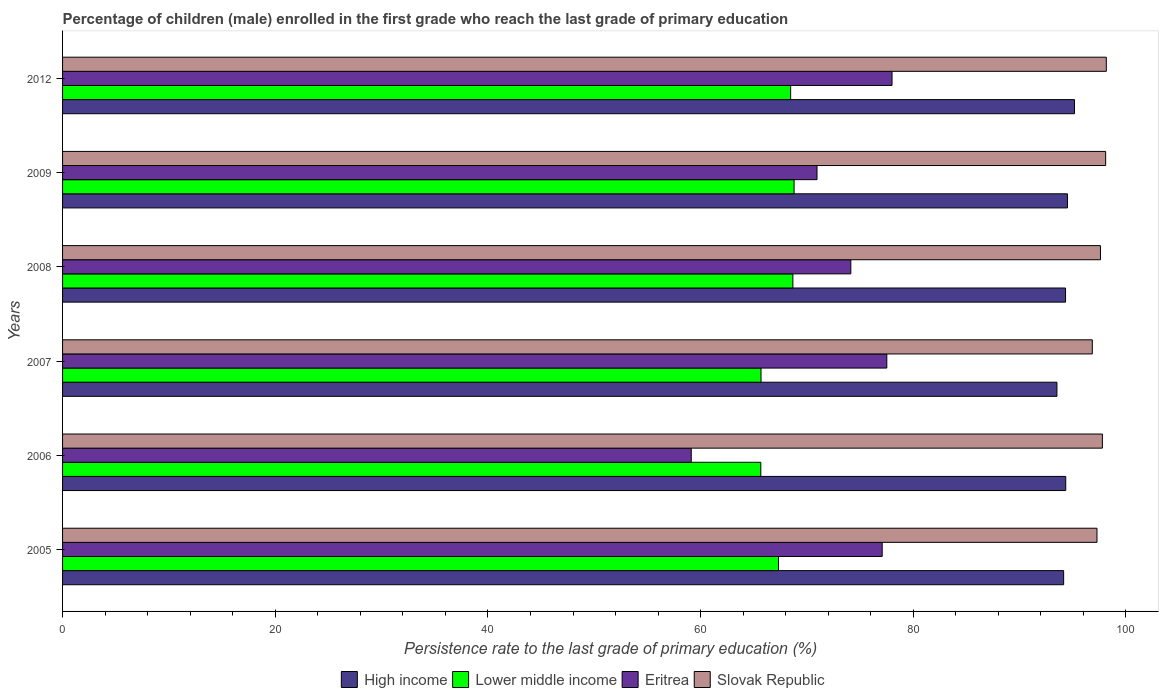How many different coloured bars are there?
Your answer should be compact. 4. Are the number of bars on each tick of the Y-axis equal?
Your answer should be very brief. Yes. How many bars are there on the 4th tick from the top?
Provide a succinct answer. 4. What is the label of the 4th group of bars from the top?
Offer a very short reply. 2007. What is the persistence rate of children in Lower middle income in 2005?
Provide a succinct answer. 67.33. Across all years, what is the maximum persistence rate of children in High income?
Make the answer very short. 95.16. Across all years, what is the minimum persistence rate of children in Slovak Republic?
Keep it short and to the point. 96.83. What is the total persistence rate of children in High income in the graph?
Your answer should be compact. 565.95. What is the difference between the persistence rate of children in High income in 2005 and that in 2012?
Keep it short and to the point. -1.02. What is the difference between the persistence rate of children in Eritrea in 2009 and the persistence rate of children in Lower middle income in 2008?
Ensure brevity in your answer.  2.27. What is the average persistence rate of children in Slovak Republic per year?
Provide a succinct answer. 97.62. In the year 2006, what is the difference between the persistence rate of children in Slovak Republic and persistence rate of children in Lower middle income?
Your answer should be compact. 32.12. In how many years, is the persistence rate of children in Eritrea greater than 36 %?
Make the answer very short. 6. What is the ratio of the persistence rate of children in High income in 2008 to that in 2009?
Give a very brief answer. 1. Is the persistence rate of children in Eritrea in 2005 less than that in 2006?
Offer a very short reply. No. Is the difference between the persistence rate of children in Slovak Republic in 2006 and 2009 greater than the difference between the persistence rate of children in Lower middle income in 2006 and 2009?
Your answer should be compact. Yes. What is the difference between the highest and the second highest persistence rate of children in Slovak Republic?
Ensure brevity in your answer.  0.06. What is the difference between the highest and the lowest persistence rate of children in Lower middle income?
Your answer should be compact. 3.13. Is the sum of the persistence rate of children in Eritrea in 2005 and 2009 greater than the maximum persistence rate of children in High income across all years?
Your response must be concise. Yes. What does the 2nd bar from the top in 2009 represents?
Keep it short and to the point. Eritrea. Is it the case that in every year, the sum of the persistence rate of children in High income and persistence rate of children in Lower middle income is greater than the persistence rate of children in Slovak Republic?
Offer a terse response. Yes. How many bars are there?
Offer a very short reply. 24. Are all the bars in the graph horizontal?
Give a very brief answer. Yes. How many years are there in the graph?
Your response must be concise. 6. What is the difference between two consecutive major ticks on the X-axis?
Give a very brief answer. 20. Does the graph contain any zero values?
Your answer should be compact. No. Does the graph contain grids?
Make the answer very short. No. What is the title of the graph?
Keep it short and to the point. Percentage of children (male) enrolled in the first grade who reach the last grade of primary education. What is the label or title of the X-axis?
Provide a succinct answer. Persistence rate to the last grade of primary education (%). What is the Persistence rate to the last grade of primary education (%) of High income in 2005?
Provide a succinct answer. 94.14. What is the Persistence rate to the last grade of primary education (%) of Lower middle income in 2005?
Offer a terse response. 67.33. What is the Persistence rate to the last grade of primary education (%) in Eritrea in 2005?
Offer a terse response. 77.08. What is the Persistence rate to the last grade of primary education (%) in Slovak Republic in 2005?
Your response must be concise. 97.27. What is the Persistence rate to the last grade of primary education (%) in High income in 2006?
Your answer should be very brief. 94.34. What is the Persistence rate to the last grade of primary education (%) in Lower middle income in 2006?
Your answer should be very brief. 65.66. What is the Persistence rate to the last grade of primary education (%) of Eritrea in 2006?
Give a very brief answer. 59.12. What is the Persistence rate to the last grade of primary education (%) of Slovak Republic in 2006?
Keep it short and to the point. 97.78. What is the Persistence rate to the last grade of primary education (%) in High income in 2007?
Provide a succinct answer. 93.51. What is the Persistence rate to the last grade of primary education (%) in Lower middle income in 2007?
Provide a short and direct response. 65.68. What is the Persistence rate to the last grade of primary education (%) in Eritrea in 2007?
Offer a very short reply. 77.51. What is the Persistence rate to the last grade of primary education (%) of Slovak Republic in 2007?
Provide a short and direct response. 96.83. What is the Persistence rate to the last grade of primary education (%) of High income in 2008?
Provide a short and direct response. 94.32. What is the Persistence rate to the last grade of primary education (%) of Lower middle income in 2008?
Your response must be concise. 68.68. What is the Persistence rate to the last grade of primary education (%) in Eritrea in 2008?
Your response must be concise. 74.13. What is the Persistence rate to the last grade of primary education (%) in Slovak Republic in 2008?
Offer a terse response. 97.6. What is the Persistence rate to the last grade of primary education (%) in High income in 2009?
Make the answer very short. 94.5. What is the Persistence rate to the last grade of primary education (%) in Lower middle income in 2009?
Your answer should be compact. 68.79. What is the Persistence rate to the last grade of primary education (%) of Eritrea in 2009?
Offer a very short reply. 70.95. What is the Persistence rate to the last grade of primary education (%) in Slovak Republic in 2009?
Your answer should be compact. 98.09. What is the Persistence rate to the last grade of primary education (%) in High income in 2012?
Your answer should be very brief. 95.16. What is the Persistence rate to the last grade of primary education (%) of Lower middle income in 2012?
Your response must be concise. 68.47. What is the Persistence rate to the last grade of primary education (%) in Eritrea in 2012?
Your response must be concise. 78. What is the Persistence rate to the last grade of primary education (%) in Slovak Republic in 2012?
Offer a very short reply. 98.15. Across all years, what is the maximum Persistence rate to the last grade of primary education (%) of High income?
Provide a short and direct response. 95.16. Across all years, what is the maximum Persistence rate to the last grade of primary education (%) in Lower middle income?
Provide a succinct answer. 68.79. Across all years, what is the maximum Persistence rate to the last grade of primary education (%) of Eritrea?
Your answer should be compact. 78. Across all years, what is the maximum Persistence rate to the last grade of primary education (%) in Slovak Republic?
Offer a terse response. 98.15. Across all years, what is the minimum Persistence rate to the last grade of primary education (%) in High income?
Provide a succinct answer. 93.51. Across all years, what is the minimum Persistence rate to the last grade of primary education (%) in Lower middle income?
Ensure brevity in your answer.  65.66. Across all years, what is the minimum Persistence rate to the last grade of primary education (%) of Eritrea?
Ensure brevity in your answer.  59.12. Across all years, what is the minimum Persistence rate to the last grade of primary education (%) in Slovak Republic?
Your answer should be very brief. 96.83. What is the total Persistence rate to the last grade of primary education (%) in High income in the graph?
Ensure brevity in your answer.  565.95. What is the total Persistence rate to the last grade of primary education (%) of Lower middle income in the graph?
Provide a succinct answer. 404.6. What is the total Persistence rate to the last grade of primary education (%) in Eritrea in the graph?
Your response must be concise. 436.78. What is the total Persistence rate to the last grade of primary education (%) of Slovak Republic in the graph?
Provide a short and direct response. 585.73. What is the difference between the Persistence rate to the last grade of primary education (%) in High income in 2005 and that in 2006?
Offer a terse response. -0.2. What is the difference between the Persistence rate to the last grade of primary education (%) in Lower middle income in 2005 and that in 2006?
Give a very brief answer. 1.67. What is the difference between the Persistence rate to the last grade of primary education (%) of Eritrea in 2005 and that in 2006?
Make the answer very short. 17.96. What is the difference between the Persistence rate to the last grade of primary education (%) in Slovak Republic in 2005 and that in 2006?
Keep it short and to the point. -0.51. What is the difference between the Persistence rate to the last grade of primary education (%) in High income in 2005 and that in 2007?
Give a very brief answer. 0.63. What is the difference between the Persistence rate to the last grade of primary education (%) in Lower middle income in 2005 and that in 2007?
Your response must be concise. 1.65. What is the difference between the Persistence rate to the last grade of primary education (%) in Eritrea in 2005 and that in 2007?
Ensure brevity in your answer.  -0.43. What is the difference between the Persistence rate to the last grade of primary education (%) in Slovak Republic in 2005 and that in 2007?
Your response must be concise. 0.44. What is the difference between the Persistence rate to the last grade of primary education (%) of High income in 2005 and that in 2008?
Give a very brief answer. -0.18. What is the difference between the Persistence rate to the last grade of primary education (%) in Lower middle income in 2005 and that in 2008?
Your response must be concise. -1.35. What is the difference between the Persistence rate to the last grade of primary education (%) in Eritrea in 2005 and that in 2008?
Offer a terse response. 2.95. What is the difference between the Persistence rate to the last grade of primary education (%) of Slovak Republic in 2005 and that in 2008?
Your answer should be compact. -0.33. What is the difference between the Persistence rate to the last grade of primary education (%) of High income in 2005 and that in 2009?
Ensure brevity in your answer.  -0.36. What is the difference between the Persistence rate to the last grade of primary education (%) of Lower middle income in 2005 and that in 2009?
Offer a very short reply. -1.46. What is the difference between the Persistence rate to the last grade of primary education (%) of Eritrea in 2005 and that in 2009?
Your response must be concise. 6.13. What is the difference between the Persistence rate to the last grade of primary education (%) in Slovak Republic in 2005 and that in 2009?
Ensure brevity in your answer.  -0.82. What is the difference between the Persistence rate to the last grade of primary education (%) of High income in 2005 and that in 2012?
Offer a very short reply. -1.02. What is the difference between the Persistence rate to the last grade of primary education (%) of Lower middle income in 2005 and that in 2012?
Make the answer very short. -1.14. What is the difference between the Persistence rate to the last grade of primary education (%) in Eritrea in 2005 and that in 2012?
Your answer should be compact. -0.93. What is the difference between the Persistence rate to the last grade of primary education (%) in Slovak Republic in 2005 and that in 2012?
Make the answer very short. -0.88. What is the difference between the Persistence rate to the last grade of primary education (%) of High income in 2006 and that in 2007?
Your answer should be very brief. 0.83. What is the difference between the Persistence rate to the last grade of primary education (%) of Lower middle income in 2006 and that in 2007?
Provide a short and direct response. -0.02. What is the difference between the Persistence rate to the last grade of primary education (%) of Eritrea in 2006 and that in 2007?
Your answer should be very brief. -18.39. What is the difference between the Persistence rate to the last grade of primary education (%) of Slovak Republic in 2006 and that in 2007?
Give a very brief answer. 0.95. What is the difference between the Persistence rate to the last grade of primary education (%) in High income in 2006 and that in 2008?
Offer a terse response. 0.02. What is the difference between the Persistence rate to the last grade of primary education (%) of Lower middle income in 2006 and that in 2008?
Offer a very short reply. -3.01. What is the difference between the Persistence rate to the last grade of primary education (%) in Eritrea in 2006 and that in 2008?
Provide a succinct answer. -15.01. What is the difference between the Persistence rate to the last grade of primary education (%) in Slovak Republic in 2006 and that in 2008?
Ensure brevity in your answer.  0.18. What is the difference between the Persistence rate to the last grade of primary education (%) of High income in 2006 and that in 2009?
Your answer should be compact. -0.16. What is the difference between the Persistence rate to the last grade of primary education (%) of Lower middle income in 2006 and that in 2009?
Ensure brevity in your answer.  -3.13. What is the difference between the Persistence rate to the last grade of primary education (%) of Eritrea in 2006 and that in 2009?
Ensure brevity in your answer.  -11.83. What is the difference between the Persistence rate to the last grade of primary education (%) in Slovak Republic in 2006 and that in 2009?
Make the answer very short. -0.31. What is the difference between the Persistence rate to the last grade of primary education (%) in High income in 2006 and that in 2012?
Your answer should be compact. -0.82. What is the difference between the Persistence rate to the last grade of primary education (%) of Lower middle income in 2006 and that in 2012?
Offer a very short reply. -2.8. What is the difference between the Persistence rate to the last grade of primary education (%) of Eritrea in 2006 and that in 2012?
Ensure brevity in your answer.  -18.88. What is the difference between the Persistence rate to the last grade of primary education (%) of Slovak Republic in 2006 and that in 2012?
Provide a short and direct response. -0.37. What is the difference between the Persistence rate to the last grade of primary education (%) in High income in 2007 and that in 2008?
Offer a terse response. -0.81. What is the difference between the Persistence rate to the last grade of primary education (%) in Lower middle income in 2007 and that in 2008?
Keep it short and to the point. -2.99. What is the difference between the Persistence rate to the last grade of primary education (%) in Eritrea in 2007 and that in 2008?
Provide a short and direct response. 3.38. What is the difference between the Persistence rate to the last grade of primary education (%) in Slovak Republic in 2007 and that in 2008?
Keep it short and to the point. -0.77. What is the difference between the Persistence rate to the last grade of primary education (%) in High income in 2007 and that in 2009?
Offer a terse response. -0.99. What is the difference between the Persistence rate to the last grade of primary education (%) of Lower middle income in 2007 and that in 2009?
Ensure brevity in your answer.  -3.11. What is the difference between the Persistence rate to the last grade of primary education (%) in Eritrea in 2007 and that in 2009?
Provide a succinct answer. 6.56. What is the difference between the Persistence rate to the last grade of primary education (%) in Slovak Republic in 2007 and that in 2009?
Ensure brevity in your answer.  -1.26. What is the difference between the Persistence rate to the last grade of primary education (%) in High income in 2007 and that in 2012?
Ensure brevity in your answer.  -1.65. What is the difference between the Persistence rate to the last grade of primary education (%) in Lower middle income in 2007 and that in 2012?
Ensure brevity in your answer.  -2.78. What is the difference between the Persistence rate to the last grade of primary education (%) in Eritrea in 2007 and that in 2012?
Make the answer very short. -0.49. What is the difference between the Persistence rate to the last grade of primary education (%) of Slovak Republic in 2007 and that in 2012?
Provide a short and direct response. -1.32. What is the difference between the Persistence rate to the last grade of primary education (%) of High income in 2008 and that in 2009?
Your response must be concise. -0.18. What is the difference between the Persistence rate to the last grade of primary education (%) in Lower middle income in 2008 and that in 2009?
Keep it short and to the point. -0.11. What is the difference between the Persistence rate to the last grade of primary education (%) of Eritrea in 2008 and that in 2009?
Provide a short and direct response. 3.18. What is the difference between the Persistence rate to the last grade of primary education (%) in Slovak Republic in 2008 and that in 2009?
Offer a terse response. -0.49. What is the difference between the Persistence rate to the last grade of primary education (%) of High income in 2008 and that in 2012?
Your response must be concise. -0.84. What is the difference between the Persistence rate to the last grade of primary education (%) in Lower middle income in 2008 and that in 2012?
Your answer should be compact. 0.21. What is the difference between the Persistence rate to the last grade of primary education (%) in Eritrea in 2008 and that in 2012?
Give a very brief answer. -3.87. What is the difference between the Persistence rate to the last grade of primary education (%) of Slovak Republic in 2008 and that in 2012?
Offer a very short reply. -0.55. What is the difference between the Persistence rate to the last grade of primary education (%) of High income in 2009 and that in 2012?
Provide a succinct answer. -0.66. What is the difference between the Persistence rate to the last grade of primary education (%) in Lower middle income in 2009 and that in 2012?
Provide a short and direct response. 0.32. What is the difference between the Persistence rate to the last grade of primary education (%) of Eritrea in 2009 and that in 2012?
Provide a short and direct response. -7.06. What is the difference between the Persistence rate to the last grade of primary education (%) of Slovak Republic in 2009 and that in 2012?
Keep it short and to the point. -0.06. What is the difference between the Persistence rate to the last grade of primary education (%) of High income in 2005 and the Persistence rate to the last grade of primary education (%) of Lower middle income in 2006?
Make the answer very short. 28.48. What is the difference between the Persistence rate to the last grade of primary education (%) in High income in 2005 and the Persistence rate to the last grade of primary education (%) in Eritrea in 2006?
Provide a short and direct response. 35.02. What is the difference between the Persistence rate to the last grade of primary education (%) in High income in 2005 and the Persistence rate to the last grade of primary education (%) in Slovak Republic in 2006?
Your answer should be compact. -3.64. What is the difference between the Persistence rate to the last grade of primary education (%) of Lower middle income in 2005 and the Persistence rate to the last grade of primary education (%) of Eritrea in 2006?
Your response must be concise. 8.21. What is the difference between the Persistence rate to the last grade of primary education (%) in Lower middle income in 2005 and the Persistence rate to the last grade of primary education (%) in Slovak Republic in 2006?
Make the answer very short. -30.45. What is the difference between the Persistence rate to the last grade of primary education (%) in Eritrea in 2005 and the Persistence rate to the last grade of primary education (%) in Slovak Republic in 2006?
Your response must be concise. -20.71. What is the difference between the Persistence rate to the last grade of primary education (%) of High income in 2005 and the Persistence rate to the last grade of primary education (%) of Lower middle income in 2007?
Offer a terse response. 28.46. What is the difference between the Persistence rate to the last grade of primary education (%) of High income in 2005 and the Persistence rate to the last grade of primary education (%) of Eritrea in 2007?
Make the answer very short. 16.63. What is the difference between the Persistence rate to the last grade of primary education (%) of High income in 2005 and the Persistence rate to the last grade of primary education (%) of Slovak Republic in 2007?
Offer a terse response. -2.69. What is the difference between the Persistence rate to the last grade of primary education (%) of Lower middle income in 2005 and the Persistence rate to the last grade of primary education (%) of Eritrea in 2007?
Ensure brevity in your answer.  -10.18. What is the difference between the Persistence rate to the last grade of primary education (%) of Lower middle income in 2005 and the Persistence rate to the last grade of primary education (%) of Slovak Republic in 2007?
Provide a succinct answer. -29.51. What is the difference between the Persistence rate to the last grade of primary education (%) of Eritrea in 2005 and the Persistence rate to the last grade of primary education (%) of Slovak Republic in 2007?
Your response must be concise. -19.76. What is the difference between the Persistence rate to the last grade of primary education (%) in High income in 2005 and the Persistence rate to the last grade of primary education (%) in Lower middle income in 2008?
Provide a succinct answer. 25.46. What is the difference between the Persistence rate to the last grade of primary education (%) of High income in 2005 and the Persistence rate to the last grade of primary education (%) of Eritrea in 2008?
Keep it short and to the point. 20.01. What is the difference between the Persistence rate to the last grade of primary education (%) of High income in 2005 and the Persistence rate to the last grade of primary education (%) of Slovak Republic in 2008?
Ensure brevity in your answer.  -3.46. What is the difference between the Persistence rate to the last grade of primary education (%) of Lower middle income in 2005 and the Persistence rate to the last grade of primary education (%) of Eritrea in 2008?
Provide a short and direct response. -6.8. What is the difference between the Persistence rate to the last grade of primary education (%) of Lower middle income in 2005 and the Persistence rate to the last grade of primary education (%) of Slovak Republic in 2008?
Provide a succinct answer. -30.27. What is the difference between the Persistence rate to the last grade of primary education (%) in Eritrea in 2005 and the Persistence rate to the last grade of primary education (%) in Slovak Republic in 2008?
Offer a very short reply. -20.53. What is the difference between the Persistence rate to the last grade of primary education (%) of High income in 2005 and the Persistence rate to the last grade of primary education (%) of Lower middle income in 2009?
Offer a very short reply. 25.35. What is the difference between the Persistence rate to the last grade of primary education (%) in High income in 2005 and the Persistence rate to the last grade of primary education (%) in Eritrea in 2009?
Offer a very short reply. 23.19. What is the difference between the Persistence rate to the last grade of primary education (%) of High income in 2005 and the Persistence rate to the last grade of primary education (%) of Slovak Republic in 2009?
Give a very brief answer. -3.95. What is the difference between the Persistence rate to the last grade of primary education (%) of Lower middle income in 2005 and the Persistence rate to the last grade of primary education (%) of Eritrea in 2009?
Ensure brevity in your answer.  -3.62. What is the difference between the Persistence rate to the last grade of primary education (%) of Lower middle income in 2005 and the Persistence rate to the last grade of primary education (%) of Slovak Republic in 2009?
Provide a succinct answer. -30.76. What is the difference between the Persistence rate to the last grade of primary education (%) in Eritrea in 2005 and the Persistence rate to the last grade of primary education (%) in Slovak Republic in 2009?
Your answer should be very brief. -21.01. What is the difference between the Persistence rate to the last grade of primary education (%) in High income in 2005 and the Persistence rate to the last grade of primary education (%) in Lower middle income in 2012?
Keep it short and to the point. 25.67. What is the difference between the Persistence rate to the last grade of primary education (%) of High income in 2005 and the Persistence rate to the last grade of primary education (%) of Eritrea in 2012?
Provide a short and direct response. 16.14. What is the difference between the Persistence rate to the last grade of primary education (%) in High income in 2005 and the Persistence rate to the last grade of primary education (%) in Slovak Republic in 2012?
Give a very brief answer. -4.01. What is the difference between the Persistence rate to the last grade of primary education (%) of Lower middle income in 2005 and the Persistence rate to the last grade of primary education (%) of Eritrea in 2012?
Keep it short and to the point. -10.67. What is the difference between the Persistence rate to the last grade of primary education (%) in Lower middle income in 2005 and the Persistence rate to the last grade of primary education (%) in Slovak Republic in 2012?
Your response must be concise. -30.82. What is the difference between the Persistence rate to the last grade of primary education (%) of Eritrea in 2005 and the Persistence rate to the last grade of primary education (%) of Slovak Republic in 2012?
Make the answer very short. -21.07. What is the difference between the Persistence rate to the last grade of primary education (%) in High income in 2006 and the Persistence rate to the last grade of primary education (%) in Lower middle income in 2007?
Your answer should be very brief. 28.65. What is the difference between the Persistence rate to the last grade of primary education (%) of High income in 2006 and the Persistence rate to the last grade of primary education (%) of Eritrea in 2007?
Provide a succinct answer. 16.83. What is the difference between the Persistence rate to the last grade of primary education (%) in High income in 2006 and the Persistence rate to the last grade of primary education (%) in Slovak Republic in 2007?
Offer a very short reply. -2.5. What is the difference between the Persistence rate to the last grade of primary education (%) of Lower middle income in 2006 and the Persistence rate to the last grade of primary education (%) of Eritrea in 2007?
Give a very brief answer. -11.85. What is the difference between the Persistence rate to the last grade of primary education (%) of Lower middle income in 2006 and the Persistence rate to the last grade of primary education (%) of Slovak Republic in 2007?
Give a very brief answer. -31.17. What is the difference between the Persistence rate to the last grade of primary education (%) of Eritrea in 2006 and the Persistence rate to the last grade of primary education (%) of Slovak Republic in 2007?
Offer a very short reply. -37.71. What is the difference between the Persistence rate to the last grade of primary education (%) in High income in 2006 and the Persistence rate to the last grade of primary education (%) in Lower middle income in 2008?
Your response must be concise. 25.66. What is the difference between the Persistence rate to the last grade of primary education (%) in High income in 2006 and the Persistence rate to the last grade of primary education (%) in Eritrea in 2008?
Provide a succinct answer. 20.21. What is the difference between the Persistence rate to the last grade of primary education (%) in High income in 2006 and the Persistence rate to the last grade of primary education (%) in Slovak Republic in 2008?
Offer a very short reply. -3.27. What is the difference between the Persistence rate to the last grade of primary education (%) in Lower middle income in 2006 and the Persistence rate to the last grade of primary education (%) in Eritrea in 2008?
Provide a short and direct response. -8.46. What is the difference between the Persistence rate to the last grade of primary education (%) in Lower middle income in 2006 and the Persistence rate to the last grade of primary education (%) in Slovak Republic in 2008?
Your answer should be compact. -31.94. What is the difference between the Persistence rate to the last grade of primary education (%) in Eritrea in 2006 and the Persistence rate to the last grade of primary education (%) in Slovak Republic in 2008?
Keep it short and to the point. -38.48. What is the difference between the Persistence rate to the last grade of primary education (%) of High income in 2006 and the Persistence rate to the last grade of primary education (%) of Lower middle income in 2009?
Your answer should be very brief. 25.55. What is the difference between the Persistence rate to the last grade of primary education (%) of High income in 2006 and the Persistence rate to the last grade of primary education (%) of Eritrea in 2009?
Ensure brevity in your answer.  23.39. What is the difference between the Persistence rate to the last grade of primary education (%) in High income in 2006 and the Persistence rate to the last grade of primary education (%) in Slovak Republic in 2009?
Your response must be concise. -3.75. What is the difference between the Persistence rate to the last grade of primary education (%) in Lower middle income in 2006 and the Persistence rate to the last grade of primary education (%) in Eritrea in 2009?
Keep it short and to the point. -5.28. What is the difference between the Persistence rate to the last grade of primary education (%) of Lower middle income in 2006 and the Persistence rate to the last grade of primary education (%) of Slovak Republic in 2009?
Ensure brevity in your answer.  -32.43. What is the difference between the Persistence rate to the last grade of primary education (%) of Eritrea in 2006 and the Persistence rate to the last grade of primary education (%) of Slovak Republic in 2009?
Provide a short and direct response. -38.97. What is the difference between the Persistence rate to the last grade of primary education (%) in High income in 2006 and the Persistence rate to the last grade of primary education (%) in Lower middle income in 2012?
Offer a very short reply. 25.87. What is the difference between the Persistence rate to the last grade of primary education (%) of High income in 2006 and the Persistence rate to the last grade of primary education (%) of Eritrea in 2012?
Keep it short and to the point. 16.33. What is the difference between the Persistence rate to the last grade of primary education (%) in High income in 2006 and the Persistence rate to the last grade of primary education (%) in Slovak Republic in 2012?
Make the answer very short. -3.82. What is the difference between the Persistence rate to the last grade of primary education (%) in Lower middle income in 2006 and the Persistence rate to the last grade of primary education (%) in Eritrea in 2012?
Your answer should be compact. -12.34. What is the difference between the Persistence rate to the last grade of primary education (%) of Lower middle income in 2006 and the Persistence rate to the last grade of primary education (%) of Slovak Republic in 2012?
Make the answer very short. -32.49. What is the difference between the Persistence rate to the last grade of primary education (%) in Eritrea in 2006 and the Persistence rate to the last grade of primary education (%) in Slovak Republic in 2012?
Offer a terse response. -39.03. What is the difference between the Persistence rate to the last grade of primary education (%) of High income in 2007 and the Persistence rate to the last grade of primary education (%) of Lower middle income in 2008?
Ensure brevity in your answer.  24.83. What is the difference between the Persistence rate to the last grade of primary education (%) of High income in 2007 and the Persistence rate to the last grade of primary education (%) of Eritrea in 2008?
Your response must be concise. 19.38. What is the difference between the Persistence rate to the last grade of primary education (%) in High income in 2007 and the Persistence rate to the last grade of primary education (%) in Slovak Republic in 2008?
Give a very brief answer. -4.09. What is the difference between the Persistence rate to the last grade of primary education (%) of Lower middle income in 2007 and the Persistence rate to the last grade of primary education (%) of Eritrea in 2008?
Provide a short and direct response. -8.44. What is the difference between the Persistence rate to the last grade of primary education (%) of Lower middle income in 2007 and the Persistence rate to the last grade of primary education (%) of Slovak Republic in 2008?
Offer a very short reply. -31.92. What is the difference between the Persistence rate to the last grade of primary education (%) of Eritrea in 2007 and the Persistence rate to the last grade of primary education (%) of Slovak Republic in 2008?
Your answer should be very brief. -20.09. What is the difference between the Persistence rate to the last grade of primary education (%) of High income in 2007 and the Persistence rate to the last grade of primary education (%) of Lower middle income in 2009?
Provide a succinct answer. 24.72. What is the difference between the Persistence rate to the last grade of primary education (%) in High income in 2007 and the Persistence rate to the last grade of primary education (%) in Eritrea in 2009?
Make the answer very short. 22.56. What is the difference between the Persistence rate to the last grade of primary education (%) of High income in 2007 and the Persistence rate to the last grade of primary education (%) of Slovak Republic in 2009?
Give a very brief answer. -4.58. What is the difference between the Persistence rate to the last grade of primary education (%) in Lower middle income in 2007 and the Persistence rate to the last grade of primary education (%) in Eritrea in 2009?
Your answer should be compact. -5.26. What is the difference between the Persistence rate to the last grade of primary education (%) in Lower middle income in 2007 and the Persistence rate to the last grade of primary education (%) in Slovak Republic in 2009?
Your answer should be very brief. -32.41. What is the difference between the Persistence rate to the last grade of primary education (%) of Eritrea in 2007 and the Persistence rate to the last grade of primary education (%) of Slovak Republic in 2009?
Your response must be concise. -20.58. What is the difference between the Persistence rate to the last grade of primary education (%) in High income in 2007 and the Persistence rate to the last grade of primary education (%) in Lower middle income in 2012?
Offer a terse response. 25.04. What is the difference between the Persistence rate to the last grade of primary education (%) in High income in 2007 and the Persistence rate to the last grade of primary education (%) in Eritrea in 2012?
Give a very brief answer. 15.51. What is the difference between the Persistence rate to the last grade of primary education (%) of High income in 2007 and the Persistence rate to the last grade of primary education (%) of Slovak Republic in 2012?
Provide a succinct answer. -4.64. What is the difference between the Persistence rate to the last grade of primary education (%) in Lower middle income in 2007 and the Persistence rate to the last grade of primary education (%) in Eritrea in 2012?
Ensure brevity in your answer.  -12.32. What is the difference between the Persistence rate to the last grade of primary education (%) in Lower middle income in 2007 and the Persistence rate to the last grade of primary education (%) in Slovak Republic in 2012?
Offer a terse response. -32.47. What is the difference between the Persistence rate to the last grade of primary education (%) in Eritrea in 2007 and the Persistence rate to the last grade of primary education (%) in Slovak Republic in 2012?
Your response must be concise. -20.64. What is the difference between the Persistence rate to the last grade of primary education (%) in High income in 2008 and the Persistence rate to the last grade of primary education (%) in Lower middle income in 2009?
Offer a very short reply. 25.53. What is the difference between the Persistence rate to the last grade of primary education (%) of High income in 2008 and the Persistence rate to the last grade of primary education (%) of Eritrea in 2009?
Give a very brief answer. 23.37. What is the difference between the Persistence rate to the last grade of primary education (%) of High income in 2008 and the Persistence rate to the last grade of primary education (%) of Slovak Republic in 2009?
Your answer should be very brief. -3.77. What is the difference between the Persistence rate to the last grade of primary education (%) in Lower middle income in 2008 and the Persistence rate to the last grade of primary education (%) in Eritrea in 2009?
Your answer should be compact. -2.27. What is the difference between the Persistence rate to the last grade of primary education (%) of Lower middle income in 2008 and the Persistence rate to the last grade of primary education (%) of Slovak Republic in 2009?
Your answer should be compact. -29.41. What is the difference between the Persistence rate to the last grade of primary education (%) in Eritrea in 2008 and the Persistence rate to the last grade of primary education (%) in Slovak Republic in 2009?
Offer a terse response. -23.96. What is the difference between the Persistence rate to the last grade of primary education (%) in High income in 2008 and the Persistence rate to the last grade of primary education (%) in Lower middle income in 2012?
Give a very brief answer. 25.85. What is the difference between the Persistence rate to the last grade of primary education (%) of High income in 2008 and the Persistence rate to the last grade of primary education (%) of Eritrea in 2012?
Provide a succinct answer. 16.32. What is the difference between the Persistence rate to the last grade of primary education (%) of High income in 2008 and the Persistence rate to the last grade of primary education (%) of Slovak Republic in 2012?
Offer a very short reply. -3.83. What is the difference between the Persistence rate to the last grade of primary education (%) in Lower middle income in 2008 and the Persistence rate to the last grade of primary education (%) in Eritrea in 2012?
Keep it short and to the point. -9.32. What is the difference between the Persistence rate to the last grade of primary education (%) in Lower middle income in 2008 and the Persistence rate to the last grade of primary education (%) in Slovak Republic in 2012?
Your answer should be compact. -29.47. What is the difference between the Persistence rate to the last grade of primary education (%) of Eritrea in 2008 and the Persistence rate to the last grade of primary education (%) of Slovak Republic in 2012?
Offer a very short reply. -24.02. What is the difference between the Persistence rate to the last grade of primary education (%) in High income in 2009 and the Persistence rate to the last grade of primary education (%) in Lower middle income in 2012?
Provide a short and direct response. 26.03. What is the difference between the Persistence rate to the last grade of primary education (%) in High income in 2009 and the Persistence rate to the last grade of primary education (%) in Eritrea in 2012?
Give a very brief answer. 16.5. What is the difference between the Persistence rate to the last grade of primary education (%) in High income in 2009 and the Persistence rate to the last grade of primary education (%) in Slovak Republic in 2012?
Keep it short and to the point. -3.65. What is the difference between the Persistence rate to the last grade of primary education (%) in Lower middle income in 2009 and the Persistence rate to the last grade of primary education (%) in Eritrea in 2012?
Your answer should be very brief. -9.21. What is the difference between the Persistence rate to the last grade of primary education (%) in Lower middle income in 2009 and the Persistence rate to the last grade of primary education (%) in Slovak Republic in 2012?
Your answer should be compact. -29.36. What is the difference between the Persistence rate to the last grade of primary education (%) in Eritrea in 2009 and the Persistence rate to the last grade of primary education (%) in Slovak Republic in 2012?
Your response must be concise. -27.2. What is the average Persistence rate to the last grade of primary education (%) of High income per year?
Ensure brevity in your answer.  94.33. What is the average Persistence rate to the last grade of primary education (%) of Lower middle income per year?
Provide a short and direct response. 67.43. What is the average Persistence rate to the last grade of primary education (%) of Eritrea per year?
Make the answer very short. 72.8. What is the average Persistence rate to the last grade of primary education (%) in Slovak Republic per year?
Provide a succinct answer. 97.62. In the year 2005, what is the difference between the Persistence rate to the last grade of primary education (%) of High income and Persistence rate to the last grade of primary education (%) of Lower middle income?
Your answer should be compact. 26.81. In the year 2005, what is the difference between the Persistence rate to the last grade of primary education (%) in High income and Persistence rate to the last grade of primary education (%) in Eritrea?
Your answer should be very brief. 17.06. In the year 2005, what is the difference between the Persistence rate to the last grade of primary education (%) of High income and Persistence rate to the last grade of primary education (%) of Slovak Republic?
Offer a terse response. -3.14. In the year 2005, what is the difference between the Persistence rate to the last grade of primary education (%) in Lower middle income and Persistence rate to the last grade of primary education (%) in Eritrea?
Provide a short and direct response. -9.75. In the year 2005, what is the difference between the Persistence rate to the last grade of primary education (%) of Lower middle income and Persistence rate to the last grade of primary education (%) of Slovak Republic?
Your answer should be very brief. -29.95. In the year 2005, what is the difference between the Persistence rate to the last grade of primary education (%) of Eritrea and Persistence rate to the last grade of primary education (%) of Slovak Republic?
Your answer should be compact. -20.2. In the year 2006, what is the difference between the Persistence rate to the last grade of primary education (%) of High income and Persistence rate to the last grade of primary education (%) of Lower middle income?
Provide a succinct answer. 28.67. In the year 2006, what is the difference between the Persistence rate to the last grade of primary education (%) in High income and Persistence rate to the last grade of primary education (%) in Eritrea?
Make the answer very short. 35.22. In the year 2006, what is the difference between the Persistence rate to the last grade of primary education (%) of High income and Persistence rate to the last grade of primary education (%) of Slovak Republic?
Your answer should be very brief. -3.45. In the year 2006, what is the difference between the Persistence rate to the last grade of primary education (%) of Lower middle income and Persistence rate to the last grade of primary education (%) of Eritrea?
Offer a very short reply. 6.54. In the year 2006, what is the difference between the Persistence rate to the last grade of primary education (%) in Lower middle income and Persistence rate to the last grade of primary education (%) in Slovak Republic?
Give a very brief answer. -32.12. In the year 2006, what is the difference between the Persistence rate to the last grade of primary education (%) in Eritrea and Persistence rate to the last grade of primary education (%) in Slovak Republic?
Give a very brief answer. -38.66. In the year 2007, what is the difference between the Persistence rate to the last grade of primary education (%) in High income and Persistence rate to the last grade of primary education (%) in Lower middle income?
Provide a short and direct response. 27.83. In the year 2007, what is the difference between the Persistence rate to the last grade of primary education (%) in High income and Persistence rate to the last grade of primary education (%) in Eritrea?
Your answer should be compact. 16. In the year 2007, what is the difference between the Persistence rate to the last grade of primary education (%) in High income and Persistence rate to the last grade of primary education (%) in Slovak Republic?
Offer a terse response. -3.33. In the year 2007, what is the difference between the Persistence rate to the last grade of primary education (%) in Lower middle income and Persistence rate to the last grade of primary education (%) in Eritrea?
Give a very brief answer. -11.83. In the year 2007, what is the difference between the Persistence rate to the last grade of primary education (%) of Lower middle income and Persistence rate to the last grade of primary education (%) of Slovak Republic?
Your answer should be very brief. -31.15. In the year 2007, what is the difference between the Persistence rate to the last grade of primary education (%) in Eritrea and Persistence rate to the last grade of primary education (%) in Slovak Republic?
Make the answer very short. -19.32. In the year 2008, what is the difference between the Persistence rate to the last grade of primary education (%) in High income and Persistence rate to the last grade of primary education (%) in Lower middle income?
Offer a very short reply. 25.64. In the year 2008, what is the difference between the Persistence rate to the last grade of primary education (%) of High income and Persistence rate to the last grade of primary education (%) of Eritrea?
Your answer should be very brief. 20.19. In the year 2008, what is the difference between the Persistence rate to the last grade of primary education (%) in High income and Persistence rate to the last grade of primary education (%) in Slovak Republic?
Ensure brevity in your answer.  -3.28. In the year 2008, what is the difference between the Persistence rate to the last grade of primary education (%) of Lower middle income and Persistence rate to the last grade of primary education (%) of Eritrea?
Give a very brief answer. -5.45. In the year 2008, what is the difference between the Persistence rate to the last grade of primary education (%) of Lower middle income and Persistence rate to the last grade of primary education (%) of Slovak Republic?
Offer a terse response. -28.92. In the year 2008, what is the difference between the Persistence rate to the last grade of primary education (%) of Eritrea and Persistence rate to the last grade of primary education (%) of Slovak Republic?
Your answer should be compact. -23.47. In the year 2009, what is the difference between the Persistence rate to the last grade of primary education (%) of High income and Persistence rate to the last grade of primary education (%) of Lower middle income?
Provide a succinct answer. 25.71. In the year 2009, what is the difference between the Persistence rate to the last grade of primary education (%) of High income and Persistence rate to the last grade of primary education (%) of Eritrea?
Provide a short and direct response. 23.55. In the year 2009, what is the difference between the Persistence rate to the last grade of primary education (%) of High income and Persistence rate to the last grade of primary education (%) of Slovak Republic?
Offer a terse response. -3.59. In the year 2009, what is the difference between the Persistence rate to the last grade of primary education (%) of Lower middle income and Persistence rate to the last grade of primary education (%) of Eritrea?
Give a very brief answer. -2.16. In the year 2009, what is the difference between the Persistence rate to the last grade of primary education (%) in Lower middle income and Persistence rate to the last grade of primary education (%) in Slovak Republic?
Your answer should be compact. -29.3. In the year 2009, what is the difference between the Persistence rate to the last grade of primary education (%) of Eritrea and Persistence rate to the last grade of primary education (%) of Slovak Republic?
Keep it short and to the point. -27.14. In the year 2012, what is the difference between the Persistence rate to the last grade of primary education (%) in High income and Persistence rate to the last grade of primary education (%) in Lower middle income?
Your answer should be very brief. 26.69. In the year 2012, what is the difference between the Persistence rate to the last grade of primary education (%) of High income and Persistence rate to the last grade of primary education (%) of Eritrea?
Keep it short and to the point. 17.16. In the year 2012, what is the difference between the Persistence rate to the last grade of primary education (%) of High income and Persistence rate to the last grade of primary education (%) of Slovak Republic?
Provide a short and direct response. -2.99. In the year 2012, what is the difference between the Persistence rate to the last grade of primary education (%) of Lower middle income and Persistence rate to the last grade of primary education (%) of Eritrea?
Ensure brevity in your answer.  -9.53. In the year 2012, what is the difference between the Persistence rate to the last grade of primary education (%) of Lower middle income and Persistence rate to the last grade of primary education (%) of Slovak Republic?
Your response must be concise. -29.68. In the year 2012, what is the difference between the Persistence rate to the last grade of primary education (%) of Eritrea and Persistence rate to the last grade of primary education (%) of Slovak Republic?
Make the answer very short. -20.15. What is the ratio of the Persistence rate to the last grade of primary education (%) in High income in 2005 to that in 2006?
Ensure brevity in your answer.  1. What is the ratio of the Persistence rate to the last grade of primary education (%) in Lower middle income in 2005 to that in 2006?
Provide a succinct answer. 1.03. What is the ratio of the Persistence rate to the last grade of primary education (%) of Eritrea in 2005 to that in 2006?
Keep it short and to the point. 1.3. What is the ratio of the Persistence rate to the last grade of primary education (%) of High income in 2005 to that in 2007?
Give a very brief answer. 1.01. What is the ratio of the Persistence rate to the last grade of primary education (%) of Lower middle income in 2005 to that in 2007?
Ensure brevity in your answer.  1.03. What is the ratio of the Persistence rate to the last grade of primary education (%) of High income in 2005 to that in 2008?
Offer a terse response. 1. What is the ratio of the Persistence rate to the last grade of primary education (%) in Lower middle income in 2005 to that in 2008?
Your answer should be very brief. 0.98. What is the ratio of the Persistence rate to the last grade of primary education (%) of Eritrea in 2005 to that in 2008?
Provide a short and direct response. 1.04. What is the ratio of the Persistence rate to the last grade of primary education (%) in Lower middle income in 2005 to that in 2009?
Make the answer very short. 0.98. What is the ratio of the Persistence rate to the last grade of primary education (%) in Eritrea in 2005 to that in 2009?
Make the answer very short. 1.09. What is the ratio of the Persistence rate to the last grade of primary education (%) in Slovak Republic in 2005 to that in 2009?
Provide a succinct answer. 0.99. What is the ratio of the Persistence rate to the last grade of primary education (%) of High income in 2005 to that in 2012?
Keep it short and to the point. 0.99. What is the ratio of the Persistence rate to the last grade of primary education (%) of Lower middle income in 2005 to that in 2012?
Offer a very short reply. 0.98. What is the ratio of the Persistence rate to the last grade of primary education (%) in Eritrea in 2005 to that in 2012?
Make the answer very short. 0.99. What is the ratio of the Persistence rate to the last grade of primary education (%) of High income in 2006 to that in 2007?
Provide a short and direct response. 1.01. What is the ratio of the Persistence rate to the last grade of primary education (%) in Eritrea in 2006 to that in 2007?
Ensure brevity in your answer.  0.76. What is the ratio of the Persistence rate to the last grade of primary education (%) in Slovak Republic in 2006 to that in 2007?
Offer a very short reply. 1.01. What is the ratio of the Persistence rate to the last grade of primary education (%) in Lower middle income in 2006 to that in 2008?
Ensure brevity in your answer.  0.96. What is the ratio of the Persistence rate to the last grade of primary education (%) in Eritrea in 2006 to that in 2008?
Your answer should be compact. 0.8. What is the ratio of the Persistence rate to the last grade of primary education (%) in Slovak Republic in 2006 to that in 2008?
Offer a very short reply. 1. What is the ratio of the Persistence rate to the last grade of primary education (%) of Lower middle income in 2006 to that in 2009?
Offer a terse response. 0.95. What is the ratio of the Persistence rate to the last grade of primary education (%) of Eritrea in 2006 to that in 2009?
Ensure brevity in your answer.  0.83. What is the ratio of the Persistence rate to the last grade of primary education (%) in Slovak Republic in 2006 to that in 2009?
Ensure brevity in your answer.  1. What is the ratio of the Persistence rate to the last grade of primary education (%) of High income in 2006 to that in 2012?
Ensure brevity in your answer.  0.99. What is the ratio of the Persistence rate to the last grade of primary education (%) in Lower middle income in 2006 to that in 2012?
Your response must be concise. 0.96. What is the ratio of the Persistence rate to the last grade of primary education (%) in Eritrea in 2006 to that in 2012?
Your response must be concise. 0.76. What is the ratio of the Persistence rate to the last grade of primary education (%) in Slovak Republic in 2006 to that in 2012?
Offer a terse response. 1. What is the ratio of the Persistence rate to the last grade of primary education (%) in High income in 2007 to that in 2008?
Offer a very short reply. 0.99. What is the ratio of the Persistence rate to the last grade of primary education (%) of Lower middle income in 2007 to that in 2008?
Offer a very short reply. 0.96. What is the ratio of the Persistence rate to the last grade of primary education (%) in Eritrea in 2007 to that in 2008?
Ensure brevity in your answer.  1.05. What is the ratio of the Persistence rate to the last grade of primary education (%) of Slovak Republic in 2007 to that in 2008?
Offer a terse response. 0.99. What is the ratio of the Persistence rate to the last grade of primary education (%) in High income in 2007 to that in 2009?
Give a very brief answer. 0.99. What is the ratio of the Persistence rate to the last grade of primary education (%) of Lower middle income in 2007 to that in 2009?
Your answer should be compact. 0.95. What is the ratio of the Persistence rate to the last grade of primary education (%) in Eritrea in 2007 to that in 2009?
Ensure brevity in your answer.  1.09. What is the ratio of the Persistence rate to the last grade of primary education (%) in Slovak Republic in 2007 to that in 2009?
Keep it short and to the point. 0.99. What is the ratio of the Persistence rate to the last grade of primary education (%) in High income in 2007 to that in 2012?
Make the answer very short. 0.98. What is the ratio of the Persistence rate to the last grade of primary education (%) in Lower middle income in 2007 to that in 2012?
Offer a very short reply. 0.96. What is the ratio of the Persistence rate to the last grade of primary education (%) of Eritrea in 2007 to that in 2012?
Provide a succinct answer. 0.99. What is the ratio of the Persistence rate to the last grade of primary education (%) in Slovak Republic in 2007 to that in 2012?
Offer a very short reply. 0.99. What is the ratio of the Persistence rate to the last grade of primary education (%) of Eritrea in 2008 to that in 2009?
Your answer should be very brief. 1.04. What is the ratio of the Persistence rate to the last grade of primary education (%) in Slovak Republic in 2008 to that in 2009?
Your response must be concise. 0.99. What is the ratio of the Persistence rate to the last grade of primary education (%) in Eritrea in 2008 to that in 2012?
Keep it short and to the point. 0.95. What is the ratio of the Persistence rate to the last grade of primary education (%) in Slovak Republic in 2008 to that in 2012?
Provide a short and direct response. 0.99. What is the ratio of the Persistence rate to the last grade of primary education (%) of High income in 2009 to that in 2012?
Ensure brevity in your answer.  0.99. What is the ratio of the Persistence rate to the last grade of primary education (%) in Eritrea in 2009 to that in 2012?
Make the answer very short. 0.91. What is the difference between the highest and the second highest Persistence rate to the last grade of primary education (%) of High income?
Your response must be concise. 0.66. What is the difference between the highest and the second highest Persistence rate to the last grade of primary education (%) of Lower middle income?
Ensure brevity in your answer.  0.11. What is the difference between the highest and the second highest Persistence rate to the last grade of primary education (%) of Eritrea?
Offer a terse response. 0.49. What is the difference between the highest and the second highest Persistence rate to the last grade of primary education (%) of Slovak Republic?
Offer a terse response. 0.06. What is the difference between the highest and the lowest Persistence rate to the last grade of primary education (%) of High income?
Make the answer very short. 1.65. What is the difference between the highest and the lowest Persistence rate to the last grade of primary education (%) of Lower middle income?
Keep it short and to the point. 3.13. What is the difference between the highest and the lowest Persistence rate to the last grade of primary education (%) in Eritrea?
Your answer should be compact. 18.88. What is the difference between the highest and the lowest Persistence rate to the last grade of primary education (%) of Slovak Republic?
Provide a short and direct response. 1.32. 